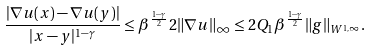Convert formula to latex. <formula><loc_0><loc_0><loc_500><loc_500>\frac { | \nabla u ( x ) - \nabla u ( y ) | } { | x - y | ^ { 1 - \gamma } } \leq \beta ^ { \frac { 1 - \gamma } { 2 } } 2 \| \nabla u \| _ { \infty } \leq 2 Q _ { 1 } \beta ^ { \frac { 1 - \gamma } { 2 } } \| g \| _ { W ^ { 1 , \infty } } .</formula> 